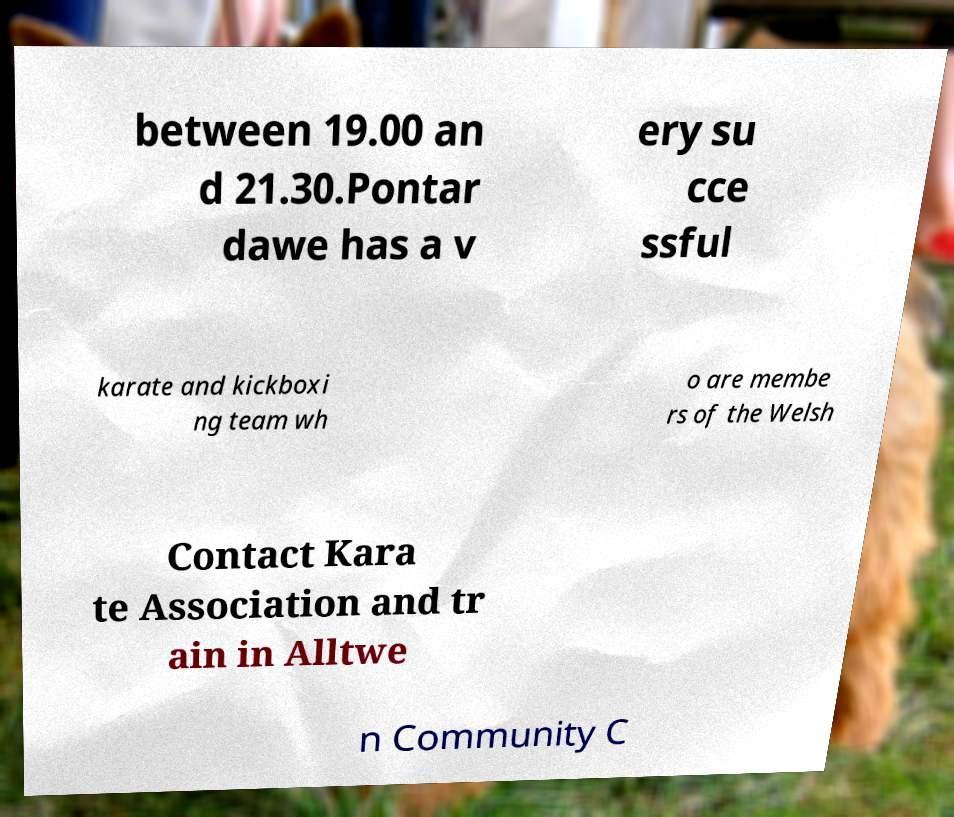For documentation purposes, I need the text within this image transcribed. Could you provide that? between 19.00 an d 21.30.Pontar dawe has a v ery su cce ssful karate and kickboxi ng team wh o are membe rs of the Welsh Contact Kara te Association and tr ain in Alltwe n Community C 